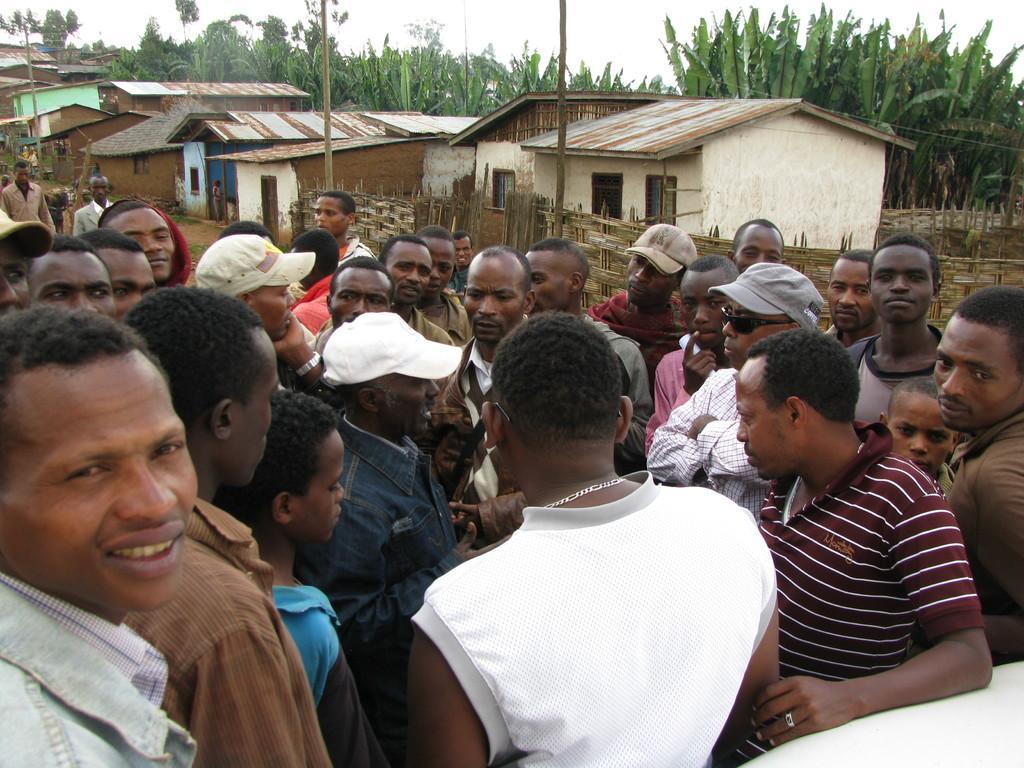Please provide a concise description of this image. In this image I can see group of people standing. In the background I can see few houses, electric poles, trees in green color and the sky is in white color. 